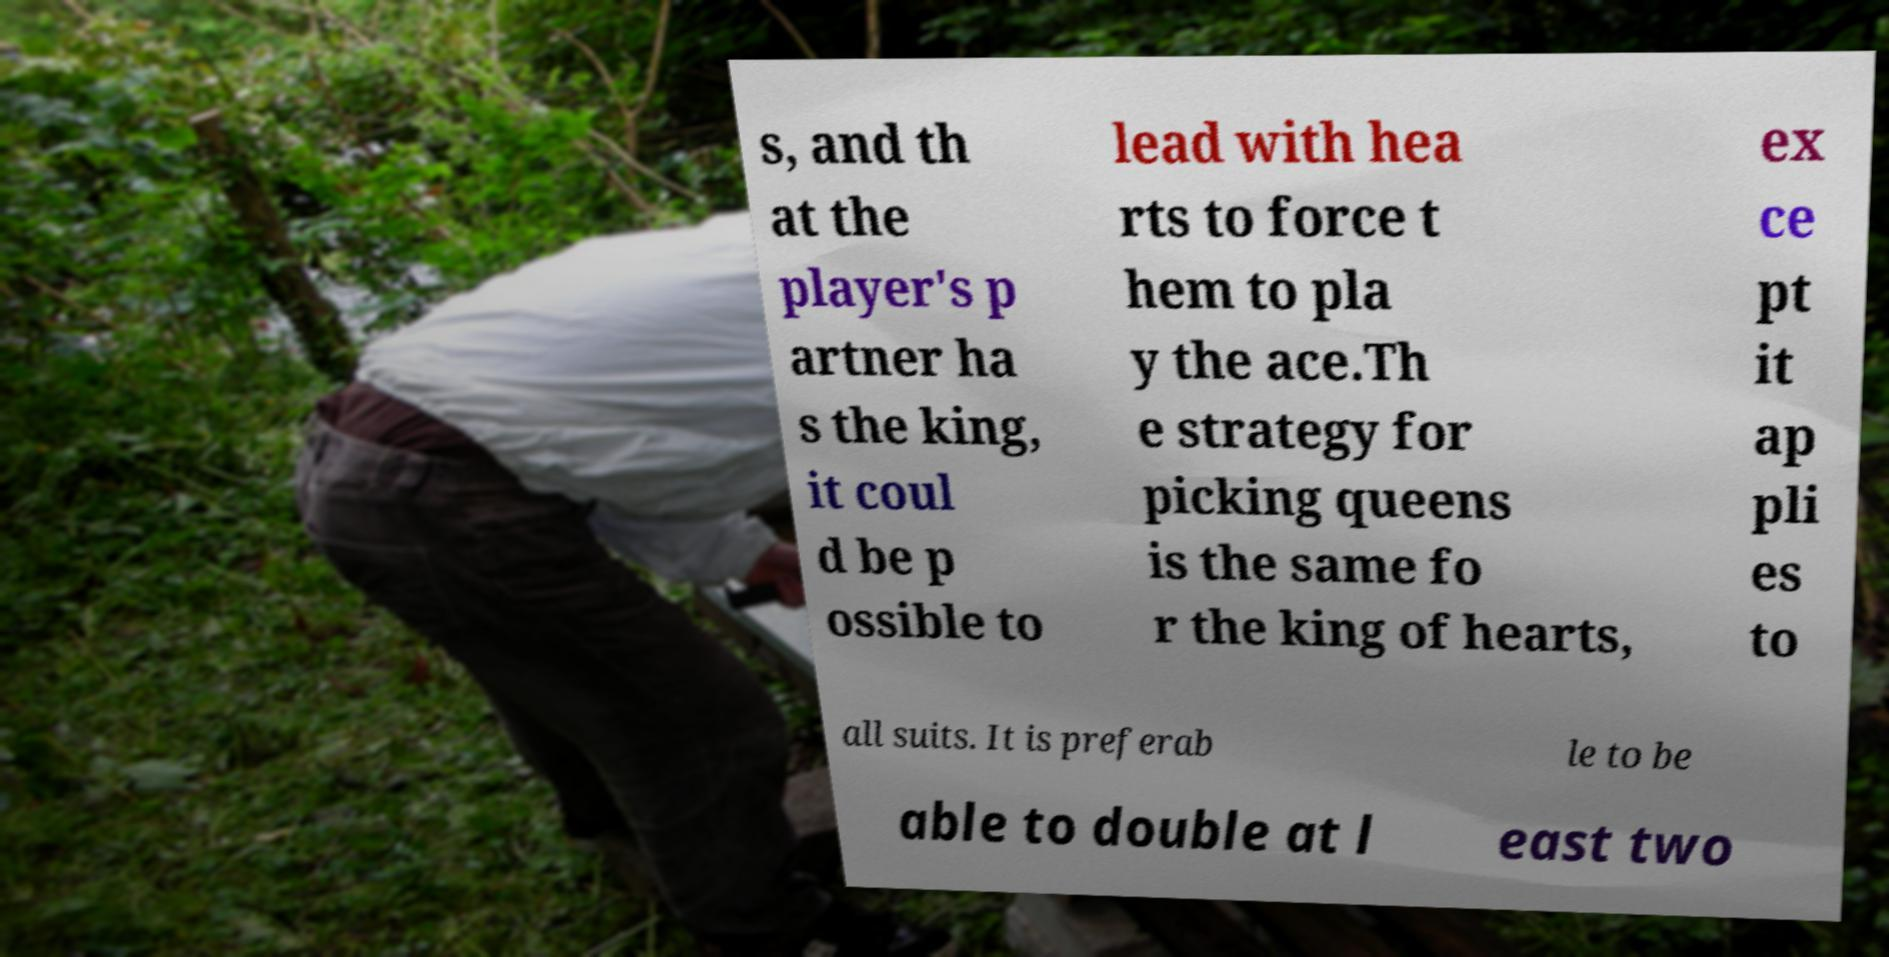What messages or text are displayed in this image? I need them in a readable, typed format. s, and th at the player's p artner ha s the king, it coul d be p ossible to lead with hea rts to force t hem to pla y the ace.Th e strategy for picking queens is the same fo r the king of hearts, ex ce pt it ap pli es to all suits. It is preferab le to be able to double at l east two 